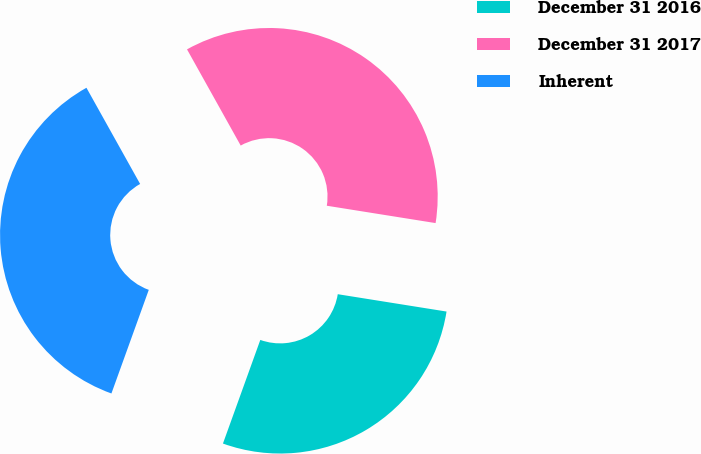Convert chart. <chart><loc_0><loc_0><loc_500><loc_500><pie_chart><fcel>December 31 2016<fcel>December 31 2017<fcel>Inherent<nl><fcel>27.99%<fcel>35.62%<fcel>36.39%<nl></chart> 